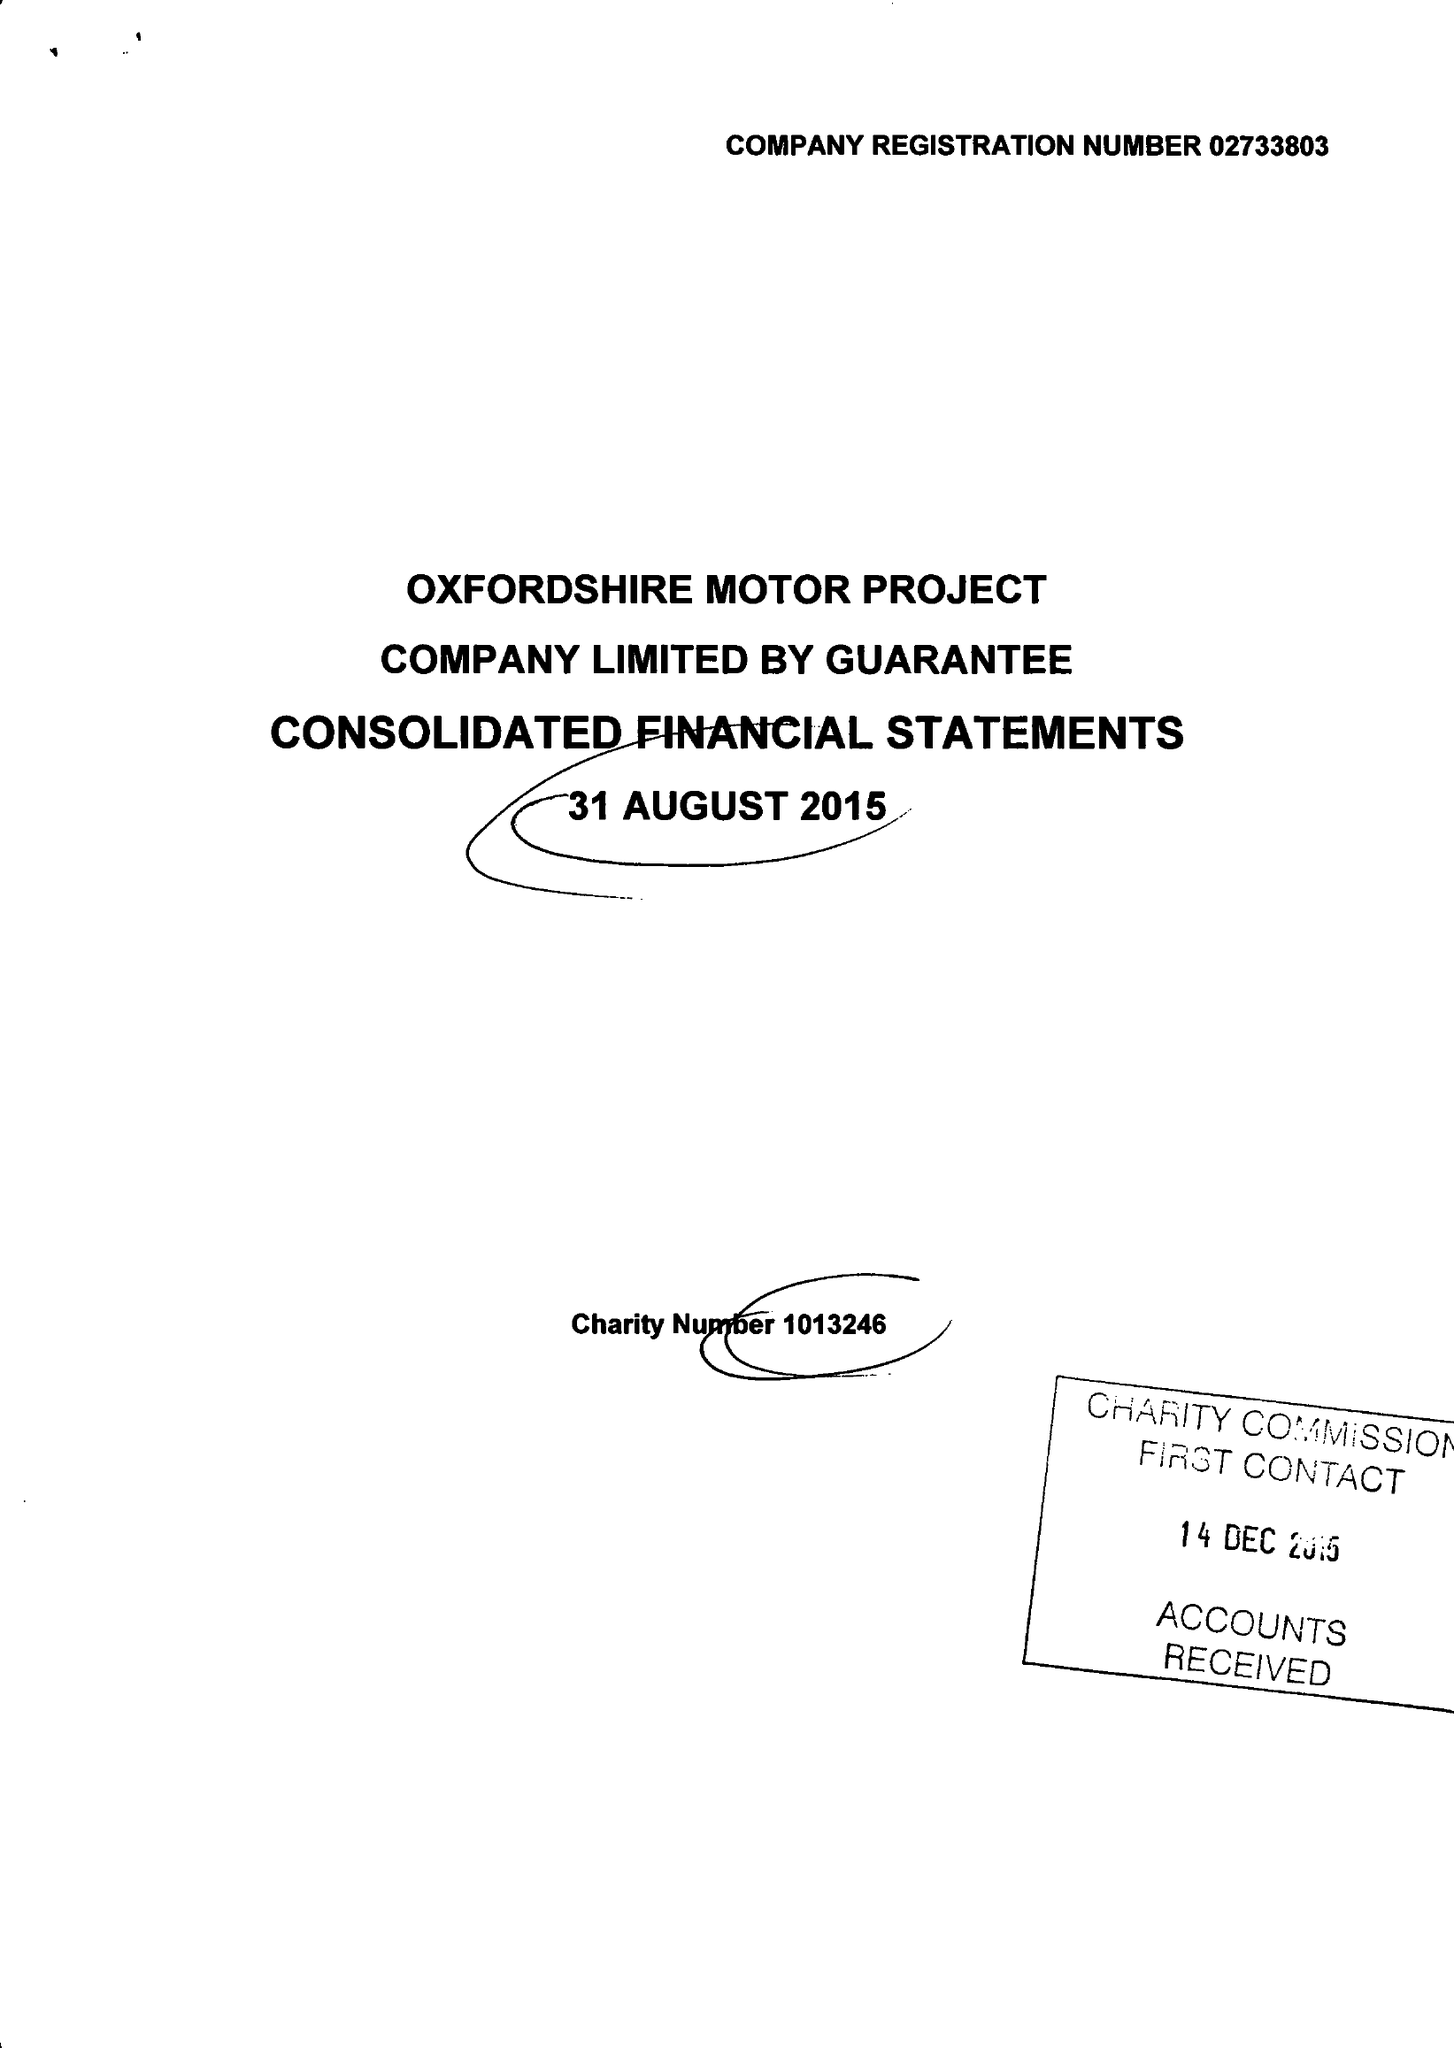What is the value for the report_date?
Answer the question using a single word or phrase. 2015-08-31 